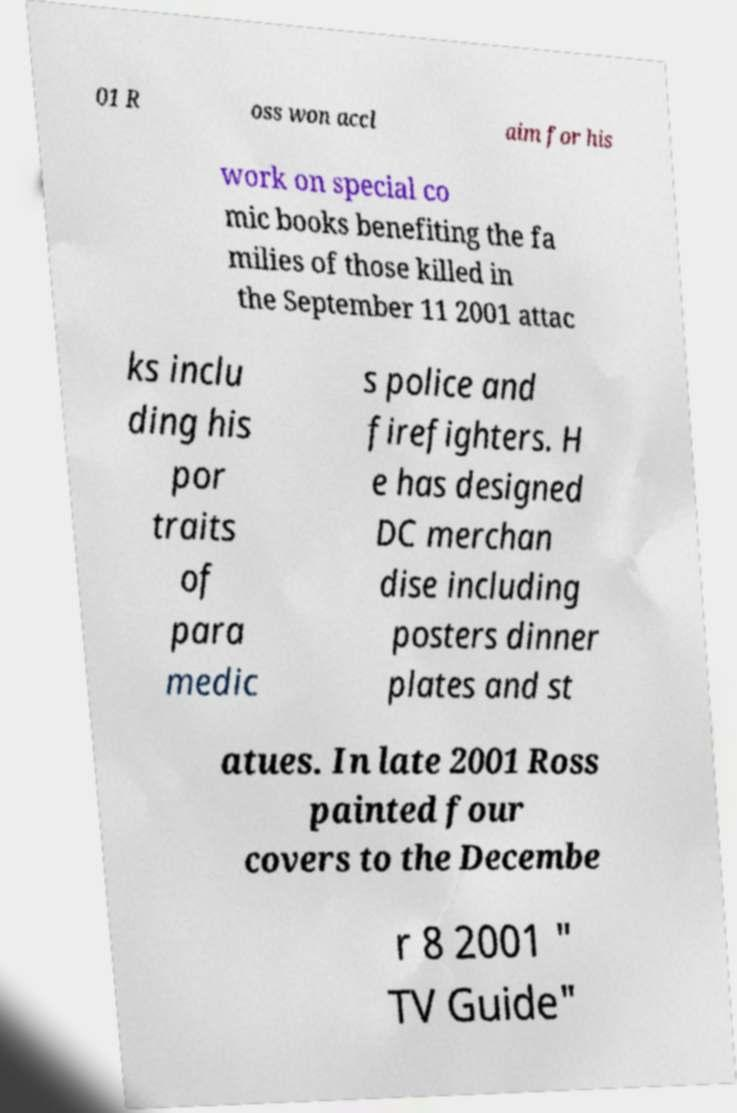There's text embedded in this image that I need extracted. Can you transcribe it verbatim? 01 R oss won accl aim for his work on special co mic books benefiting the fa milies of those killed in the September 11 2001 attac ks inclu ding his por traits of para medic s police and firefighters. H e has designed DC merchan dise including posters dinner plates and st atues. In late 2001 Ross painted four covers to the Decembe r 8 2001 " TV Guide" 